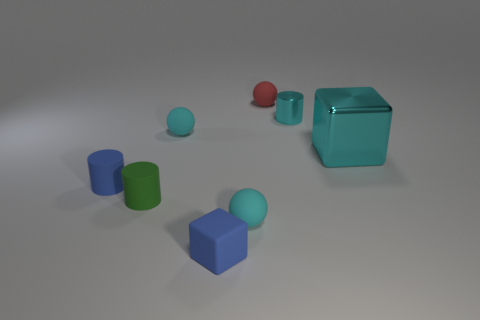Add 1 large yellow matte cylinders. How many objects exist? 9 Subtract all balls. How many objects are left? 5 Subtract 0 gray blocks. How many objects are left? 8 Subtract all big green blocks. Subtract all tiny blocks. How many objects are left? 7 Add 4 tiny blue rubber things. How many tiny blue rubber things are left? 6 Add 3 tiny blue rubber cylinders. How many tiny blue rubber cylinders exist? 4 